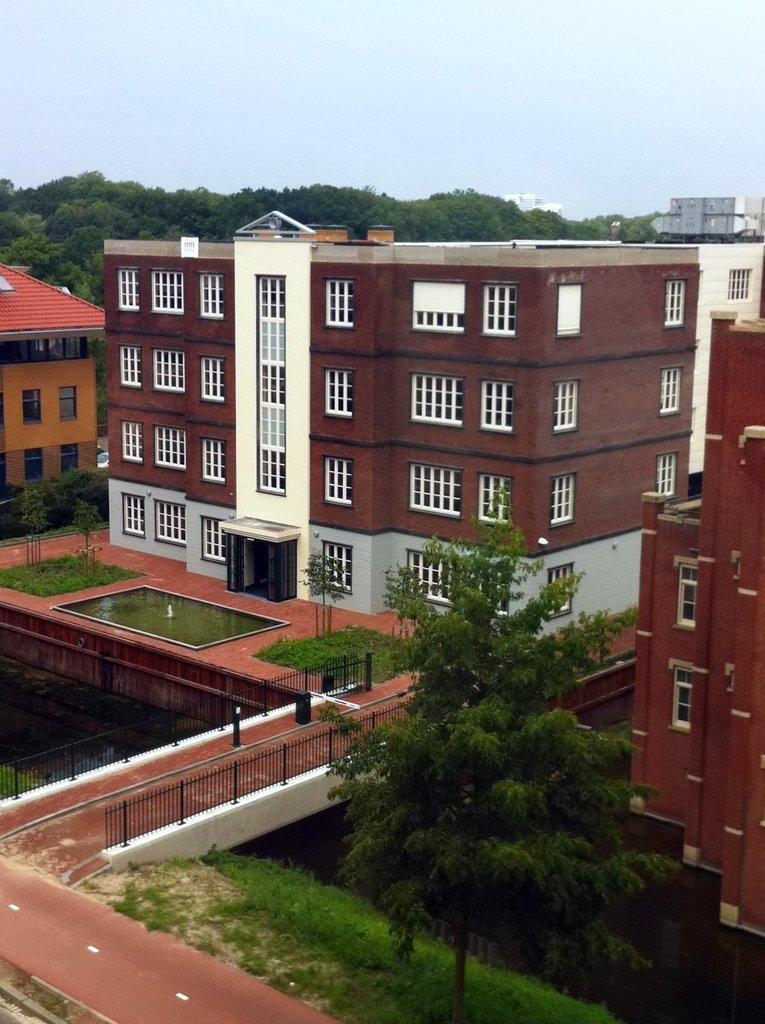What type of vegetation can be seen in the image? There is grass and trees in the image. What type of man-made structures are present in the image? There are roads, fences, buildings with windows, and some objects in the image. What natural element is visible in the image? There is water visible in the image. What is visible in the background of the image? The sky is visible in the background of the image. Where is the sofa located in the image? There is no sofa present in the image. What color is the crook's wrist in the image? There is no crook or wrist present in the image. 